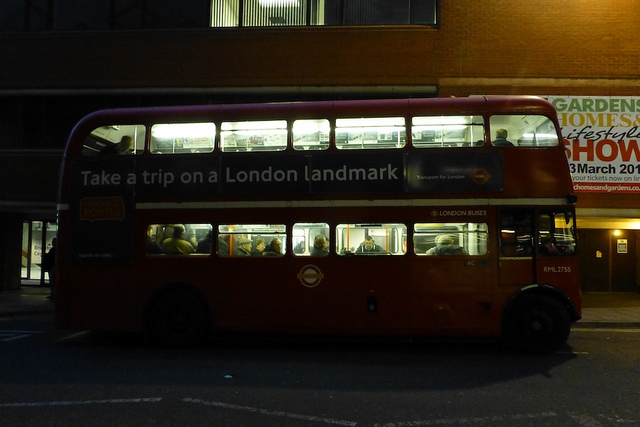Can you describe the surroundings of the bus? The bus is situated in an urban environment, likely a city street. The buildings in the background suggest a commercial or residential area. There's also an advertisement on a wall, indicating it might be a bus stop or near a point of interest. 